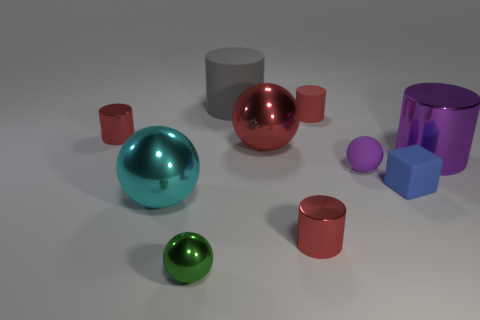What is the color of the other large shiny object that is the same shape as the large gray object?
Give a very brief answer. Purple. What number of things are either big yellow cylinders or large metallic objects right of the big gray object?
Provide a succinct answer. 2. Are there fewer big purple metal objects that are behind the gray rubber cylinder than small yellow matte blocks?
Offer a terse response. No. There is a matte cube in front of the small matte object that is behind the small shiny cylinder behind the cube; how big is it?
Ensure brevity in your answer.  Small. There is a tiny thing that is right of the cyan thing and behind the big red ball; what color is it?
Give a very brief answer. Red. How many blue matte cylinders are there?
Keep it short and to the point. 0. Are the tiny purple ball and the cyan sphere made of the same material?
Your answer should be compact. No. Is the size of the red object that is to the left of the small green object the same as the cylinder that is in front of the big purple shiny object?
Offer a very short reply. Yes. Are there fewer big red matte cylinders than purple matte things?
Give a very brief answer. Yes. What number of rubber things are either tiny cyan cylinders or green things?
Provide a succinct answer. 0. 